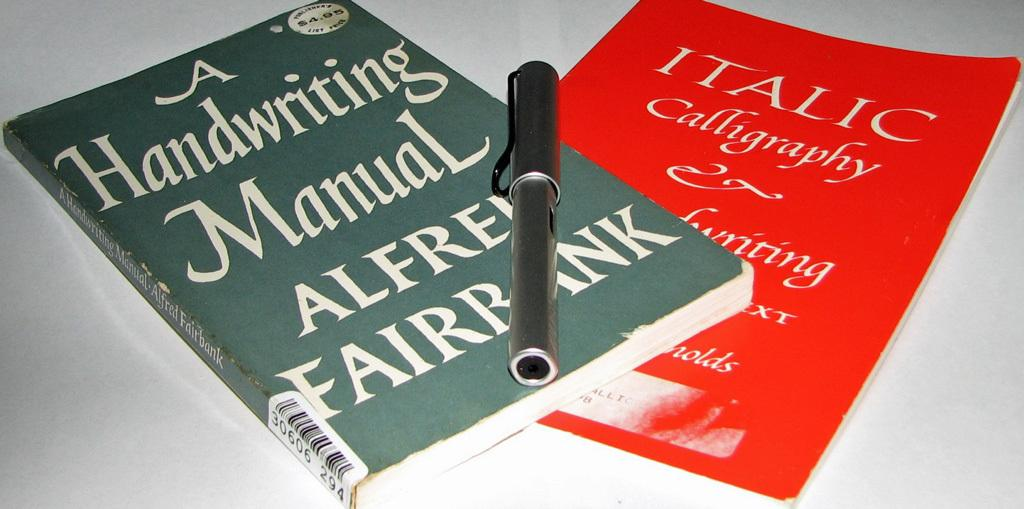<image>
Give a short and clear explanation of the subsequent image. Two books on handwriting styles lay partially stacked. 